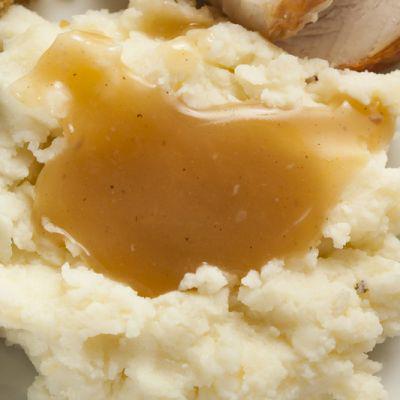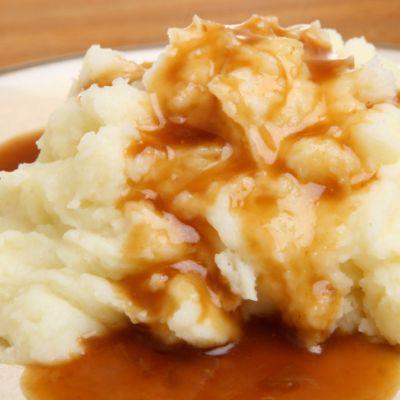The first image is the image on the left, the second image is the image on the right. Analyze the images presented: Is the assertion "An eating utensil can be seen in the image on the left." valid? Answer yes or no. No. 